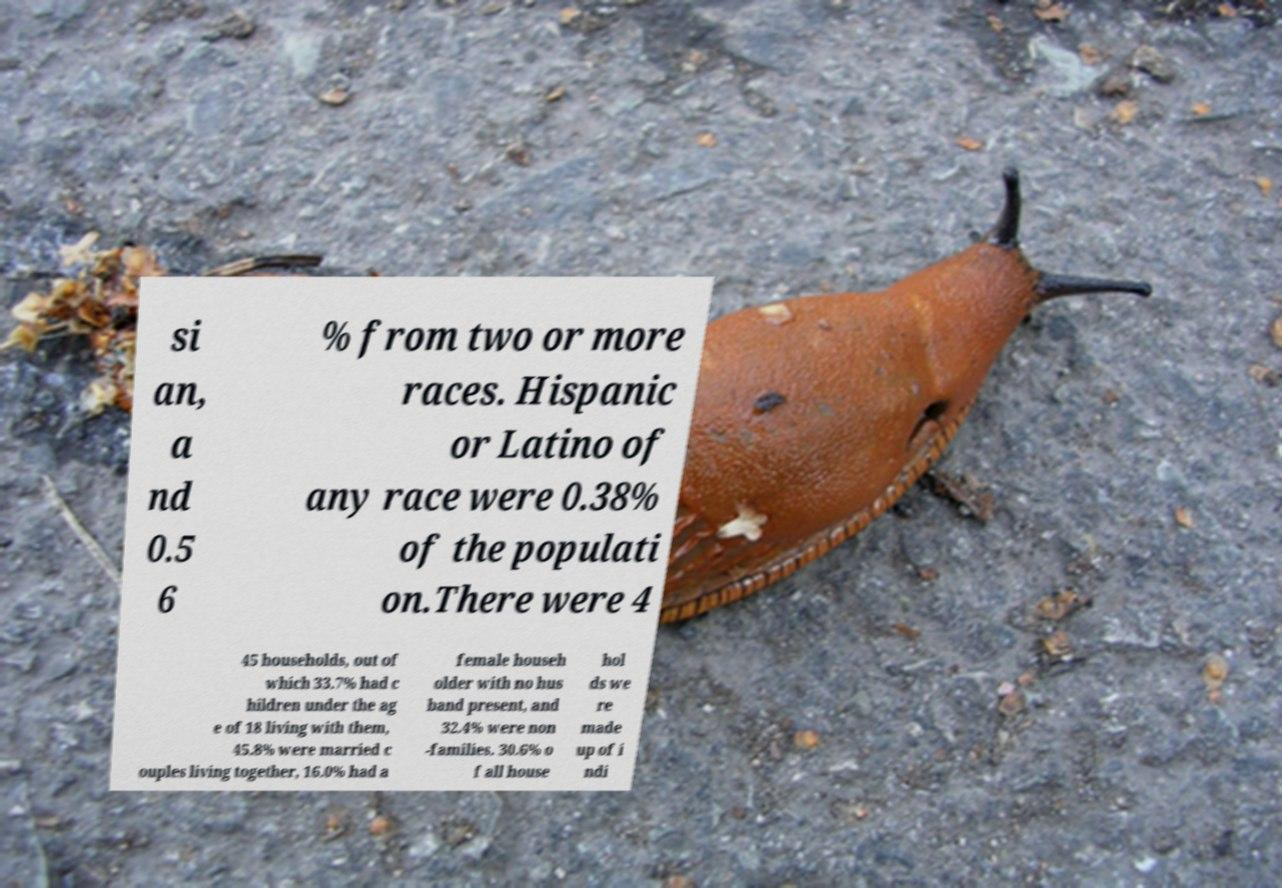Please identify and transcribe the text found in this image. si an, a nd 0.5 6 % from two or more races. Hispanic or Latino of any race were 0.38% of the populati on.There were 4 45 households, out of which 33.7% had c hildren under the ag e of 18 living with them, 45.8% were married c ouples living together, 16.0% had a female househ older with no hus band present, and 32.4% were non -families. 30.6% o f all house hol ds we re made up of i ndi 